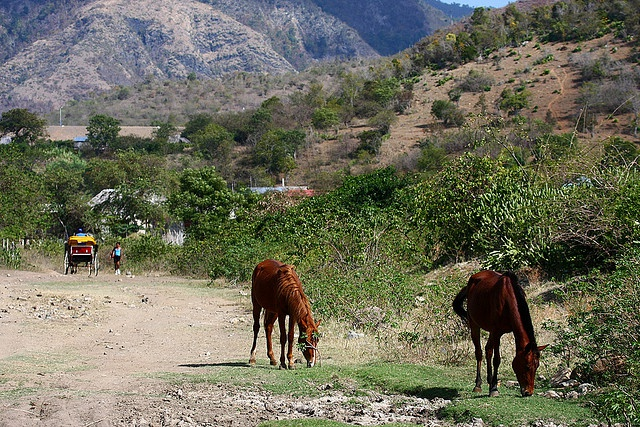Describe the objects in this image and their specific colors. I can see horse in navy, black, maroon, gray, and olive tones, horse in navy, black, maroon, and brown tones, people in navy, black, brown, maroon, and gray tones, and people in navy, black, and lightblue tones in this image. 